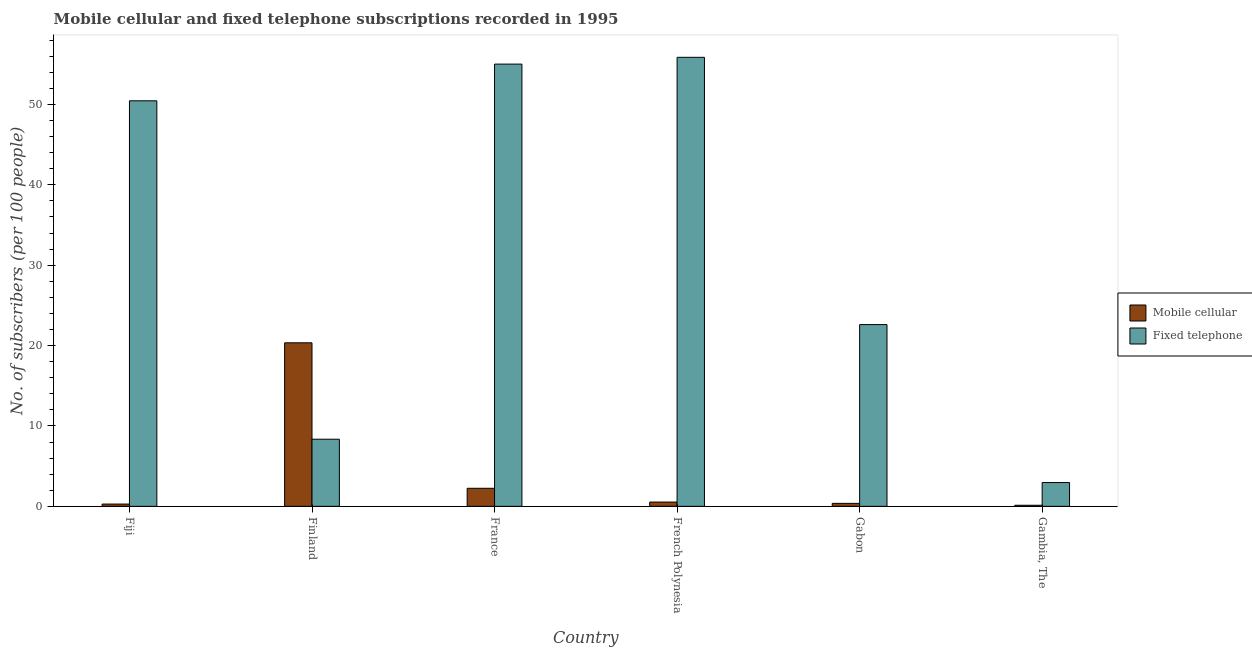How many different coloured bars are there?
Your answer should be very brief. 2. Are the number of bars on each tick of the X-axis equal?
Keep it short and to the point. Yes. How many bars are there on the 1st tick from the left?
Your answer should be very brief. 2. How many bars are there on the 6th tick from the right?
Make the answer very short. 2. What is the label of the 4th group of bars from the left?
Ensure brevity in your answer.  French Polynesia. What is the number of mobile cellular subscribers in France?
Offer a terse response. 2.25. Across all countries, what is the maximum number of mobile cellular subscribers?
Offer a terse response. 20.34. Across all countries, what is the minimum number of fixed telephone subscribers?
Your answer should be compact. 2.96. In which country was the number of fixed telephone subscribers maximum?
Give a very brief answer. French Polynesia. In which country was the number of mobile cellular subscribers minimum?
Ensure brevity in your answer.  Gambia, The. What is the total number of mobile cellular subscribers in the graph?
Ensure brevity in your answer.  23.91. What is the difference between the number of fixed telephone subscribers in Finland and that in Gambia, The?
Your answer should be very brief. 5.39. What is the difference between the number of fixed telephone subscribers in Finland and the number of mobile cellular subscribers in France?
Keep it short and to the point. 6.11. What is the average number of fixed telephone subscribers per country?
Offer a terse response. 32.54. What is the difference between the number of fixed telephone subscribers and number of mobile cellular subscribers in France?
Make the answer very short. 52.76. In how many countries, is the number of mobile cellular subscribers greater than 14 ?
Offer a terse response. 1. What is the ratio of the number of mobile cellular subscribers in France to that in Gambia, The?
Offer a terse response. 16.59. Is the number of mobile cellular subscribers in France less than that in Gambia, The?
Your answer should be compact. No. What is the difference between the highest and the second highest number of mobile cellular subscribers?
Make the answer very short. 18.1. What is the difference between the highest and the lowest number of fixed telephone subscribers?
Keep it short and to the point. 52.89. In how many countries, is the number of mobile cellular subscribers greater than the average number of mobile cellular subscribers taken over all countries?
Offer a terse response. 1. Is the sum of the number of fixed telephone subscribers in France and French Polynesia greater than the maximum number of mobile cellular subscribers across all countries?
Your answer should be compact. Yes. What does the 1st bar from the left in Finland represents?
Your answer should be compact. Mobile cellular. What does the 2nd bar from the right in Finland represents?
Provide a short and direct response. Mobile cellular. Are all the bars in the graph horizontal?
Your answer should be very brief. No. How many countries are there in the graph?
Provide a succinct answer. 6. Does the graph contain any zero values?
Your response must be concise. No. Where does the legend appear in the graph?
Provide a short and direct response. Center right. How are the legend labels stacked?
Ensure brevity in your answer.  Vertical. What is the title of the graph?
Offer a terse response. Mobile cellular and fixed telephone subscriptions recorded in 1995. Does "Investment" appear as one of the legend labels in the graph?
Provide a short and direct response. No. What is the label or title of the X-axis?
Ensure brevity in your answer.  Country. What is the label or title of the Y-axis?
Give a very brief answer. No. of subscribers (per 100 people). What is the No. of subscribers (per 100 people) in Mobile cellular in Fiji?
Keep it short and to the point. 0.28. What is the No. of subscribers (per 100 people) in Fixed telephone in Fiji?
Provide a short and direct response. 50.45. What is the No. of subscribers (per 100 people) of Mobile cellular in Finland?
Make the answer very short. 20.34. What is the No. of subscribers (per 100 people) of Fixed telephone in Finland?
Provide a succinct answer. 8.35. What is the No. of subscribers (per 100 people) of Mobile cellular in France?
Provide a short and direct response. 2.25. What is the No. of subscribers (per 100 people) in Fixed telephone in France?
Provide a short and direct response. 55.01. What is the No. of subscribers (per 100 people) in Mobile cellular in French Polynesia?
Your answer should be compact. 0.53. What is the No. of subscribers (per 100 people) in Fixed telephone in French Polynesia?
Ensure brevity in your answer.  55.85. What is the No. of subscribers (per 100 people) of Mobile cellular in Gabon?
Your answer should be very brief. 0.37. What is the No. of subscribers (per 100 people) of Fixed telephone in Gabon?
Provide a short and direct response. 22.61. What is the No. of subscribers (per 100 people) in Mobile cellular in Gambia, The?
Provide a short and direct response. 0.14. What is the No. of subscribers (per 100 people) of Fixed telephone in Gambia, The?
Your response must be concise. 2.96. Across all countries, what is the maximum No. of subscribers (per 100 people) of Mobile cellular?
Offer a terse response. 20.34. Across all countries, what is the maximum No. of subscribers (per 100 people) in Fixed telephone?
Your answer should be compact. 55.85. Across all countries, what is the minimum No. of subscribers (per 100 people) in Mobile cellular?
Make the answer very short. 0.14. Across all countries, what is the minimum No. of subscribers (per 100 people) of Fixed telephone?
Keep it short and to the point. 2.96. What is the total No. of subscribers (per 100 people) in Mobile cellular in the graph?
Make the answer very short. 23.91. What is the total No. of subscribers (per 100 people) of Fixed telephone in the graph?
Provide a succinct answer. 195.23. What is the difference between the No. of subscribers (per 100 people) in Mobile cellular in Fiji and that in Finland?
Your answer should be very brief. -20.06. What is the difference between the No. of subscribers (per 100 people) in Fixed telephone in Fiji and that in Finland?
Offer a terse response. 42.09. What is the difference between the No. of subscribers (per 100 people) in Mobile cellular in Fiji and that in France?
Your answer should be very brief. -1.96. What is the difference between the No. of subscribers (per 100 people) in Fixed telephone in Fiji and that in France?
Your answer should be very brief. -4.56. What is the difference between the No. of subscribers (per 100 people) in Mobile cellular in Fiji and that in French Polynesia?
Your answer should be very brief. -0.25. What is the difference between the No. of subscribers (per 100 people) of Fixed telephone in Fiji and that in French Polynesia?
Your answer should be compact. -5.41. What is the difference between the No. of subscribers (per 100 people) of Mobile cellular in Fiji and that in Gabon?
Make the answer very short. -0.09. What is the difference between the No. of subscribers (per 100 people) of Fixed telephone in Fiji and that in Gabon?
Your answer should be very brief. 27.84. What is the difference between the No. of subscribers (per 100 people) of Mobile cellular in Fiji and that in Gambia, The?
Make the answer very short. 0.15. What is the difference between the No. of subscribers (per 100 people) in Fixed telephone in Fiji and that in Gambia, The?
Offer a terse response. 47.48. What is the difference between the No. of subscribers (per 100 people) of Mobile cellular in Finland and that in France?
Offer a very short reply. 18.1. What is the difference between the No. of subscribers (per 100 people) in Fixed telephone in Finland and that in France?
Make the answer very short. -46.66. What is the difference between the No. of subscribers (per 100 people) in Mobile cellular in Finland and that in French Polynesia?
Make the answer very short. 19.81. What is the difference between the No. of subscribers (per 100 people) of Fixed telephone in Finland and that in French Polynesia?
Offer a terse response. -47.5. What is the difference between the No. of subscribers (per 100 people) in Mobile cellular in Finland and that in Gabon?
Make the answer very short. 19.97. What is the difference between the No. of subscribers (per 100 people) in Fixed telephone in Finland and that in Gabon?
Make the answer very short. -14.26. What is the difference between the No. of subscribers (per 100 people) in Mobile cellular in Finland and that in Gambia, The?
Your answer should be very brief. 20.21. What is the difference between the No. of subscribers (per 100 people) in Fixed telephone in Finland and that in Gambia, The?
Make the answer very short. 5.39. What is the difference between the No. of subscribers (per 100 people) in Mobile cellular in France and that in French Polynesia?
Provide a short and direct response. 1.71. What is the difference between the No. of subscribers (per 100 people) in Fixed telephone in France and that in French Polynesia?
Keep it short and to the point. -0.84. What is the difference between the No. of subscribers (per 100 people) of Mobile cellular in France and that in Gabon?
Provide a short and direct response. 1.88. What is the difference between the No. of subscribers (per 100 people) in Fixed telephone in France and that in Gabon?
Give a very brief answer. 32.4. What is the difference between the No. of subscribers (per 100 people) of Mobile cellular in France and that in Gambia, The?
Make the answer very short. 2.11. What is the difference between the No. of subscribers (per 100 people) in Fixed telephone in France and that in Gambia, The?
Ensure brevity in your answer.  52.05. What is the difference between the No. of subscribers (per 100 people) in Mobile cellular in French Polynesia and that in Gabon?
Provide a short and direct response. 0.16. What is the difference between the No. of subscribers (per 100 people) of Fixed telephone in French Polynesia and that in Gabon?
Provide a succinct answer. 33.24. What is the difference between the No. of subscribers (per 100 people) of Mobile cellular in French Polynesia and that in Gambia, The?
Offer a very short reply. 0.4. What is the difference between the No. of subscribers (per 100 people) in Fixed telephone in French Polynesia and that in Gambia, The?
Keep it short and to the point. 52.89. What is the difference between the No. of subscribers (per 100 people) in Mobile cellular in Gabon and that in Gambia, The?
Your answer should be very brief. 0.23. What is the difference between the No. of subscribers (per 100 people) in Fixed telephone in Gabon and that in Gambia, The?
Offer a terse response. 19.65. What is the difference between the No. of subscribers (per 100 people) of Mobile cellular in Fiji and the No. of subscribers (per 100 people) of Fixed telephone in Finland?
Your answer should be very brief. -8.07. What is the difference between the No. of subscribers (per 100 people) of Mobile cellular in Fiji and the No. of subscribers (per 100 people) of Fixed telephone in France?
Offer a terse response. -54.73. What is the difference between the No. of subscribers (per 100 people) of Mobile cellular in Fiji and the No. of subscribers (per 100 people) of Fixed telephone in French Polynesia?
Your answer should be compact. -55.57. What is the difference between the No. of subscribers (per 100 people) in Mobile cellular in Fiji and the No. of subscribers (per 100 people) in Fixed telephone in Gabon?
Provide a short and direct response. -22.33. What is the difference between the No. of subscribers (per 100 people) of Mobile cellular in Fiji and the No. of subscribers (per 100 people) of Fixed telephone in Gambia, The?
Provide a succinct answer. -2.68. What is the difference between the No. of subscribers (per 100 people) of Mobile cellular in Finland and the No. of subscribers (per 100 people) of Fixed telephone in France?
Make the answer very short. -34.67. What is the difference between the No. of subscribers (per 100 people) in Mobile cellular in Finland and the No. of subscribers (per 100 people) in Fixed telephone in French Polynesia?
Give a very brief answer. -35.51. What is the difference between the No. of subscribers (per 100 people) of Mobile cellular in Finland and the No. of subscribers (per 100 people) of Fixed telephone in Gabon?
Your answer should be compact. -2.27. What is the difference between the No. of subscribers (per 100 people) in Mobile cellular in Finland and the No. of subscribers (per 100 people) in Fixed telephone in Gambia, The?
Give a very brief answer. 17.38. What is the difference between the No. of subscribers (per 100 people) in Mobile cellular in France and the No. of subscribers (per 100 people) in Fixed telephone in French Polynesia?
Give a very brief answer. -53.61. What is the difference between the No. of subscribers (per 100 people) of Mobile cellular in France and the No. of subscribers (per 100 people) of Fixed telephone in Gabon?
Your answer should be very brief. -20.36. What is the difference between the No. of subscribers (per 100 people) in Mobile cellular in France and the No. of subscribers (per 100 people) in Fixed telephone in Gambia, The?
Offer a very short reply. -0.72. What is the difference between the No. of subscribers (per 100 people) in Mobile cellular in French Polynesia and the No. of subscribers (per 100 people) in Fixed telephone in Gabon?
Provide a succinct answer. -22.07. What is the difference between the No. of subscribers (per 100 people) in Mobile cellular in French Polynesia and the No. of subscribers (per 100 people) in Fixed telephone in Gambia, The?
Ensure brevity in your answer.  -2.43. What is the difference between the No. of subscribers (per 100 people) of Mobile cellular in Gabon and the No. of subscribers (per 100 people) of Fixed telephone in Gambia, The?
Offer a terse response. -2.59. What is the average No. of subscribers (per 100 people) of Mobile cellular per country?
Your response must be concise. 3.99. What is the average No. of subscribers (per 100 people) of Fixed telephone per country?
Offer a very short reply. 32.54. What is the difference between the No. of subscribers (per 100 people) of Mobile cellular and No. of subscribers (per 100 people) of Fixed telephone in Fiji?
Make the answer very short. -50.16. What is the difference between the No. of subscribers (per 100 people) in Mobile cellular and No. of subscribers (per 100 people) in Fixed telephone in Finland?
Ensure brevity in your answer.  11.99. What is the difference between the No. of subscribers (per 100 people) of Mobile cellular and No. of subscribers (per 100 people) of Fixed telephone in France?
Your response must be concise. -52.76. What is the difference between the No. of subscribers (per 100 people) of Mobile cellular and No. of subscribers (per 100 people) of Fixed telephone in French Polynesia?
Your answer should be compact. -55.32. What is the difference between the No. of subscribers (per 100 people) in Mobile cellular and No. of subscribers (per 100 people) in Fixed telephone in Gabon?
Give a very brief answer. -22.24. What is the difference between the No. of subscribers (per 100 people) of Mobile cellular and No. of subscribers (per 100 people) of Fixed telephone in Gambia, The?
Offer a terse response. -2.83. What is the ratio of the No. of subscribers (per 100 people) of Mobile cellular in Fiji to that in Finland?
Your response must be concise. 0.01. What is the ratio of the No. of subscribers (per 100 people) in Fixed telephone in Fiji to that in Finland?
Your response must be concise. 6.04. What is the ratio of the No. of subscribers (per 100 people) in Mobile cellular in Fiji to that in France?
Your response must be concise. 0.13. What is the ratio of the No. of subscribers (per 100 people) in Fixed telephone in Fiji to that in France?
Ensure brevity in your answer.  0.92. What is the ratio of the No. of subscribers (per 100 people) in Mobile cellular in Fiji to that in French Polynesia?
Make the answer very short. 0.53. What is the ratio of the No. of subscribers (per 100 people) in Fixed telephone in Fiji to that in French Polynesia?
Your answer should be very brief. 0.9. What is the ratio of the No. of subscribers (per 100 people) in Mobile cellular in Fiji to that in Gabon?
Ensure brevity in your answer.  0.77. What is the ratio of the No. of subscribers (per 100 people) in Fixed telephone in Fiji to that in Gabon?
Your answer should be compact. 2.23. What is the ratio of the No. of subscribers (per 100 people) of Mobile cellular in Fiji to that in Gambia, The?
Give a very brief answer. 2.1. What is the ratio of the No. of subscribers (per 100 people) in Fixed telephone in Fiji to that in Gambia, The?
Keep it short and to the point. 17.03. What is the ratio of the No. of subscribers (per 100 people) in Mobile cellular in Finland to that in France?
Offer a very short reply. 9.06. What is the ratio of the No. of subscribers (per 100 people) of Fixed telephone in Finland to that in France?
Offer a terse response. 0.15. What is the ratio of the No. of subscribers (per 100 people) in Mobile cellular in Finland to that in French Polynesia?
Offer a terse response. 38.07. What is the ratio of the No. of subscribers (per 100 people) in Fixed telephone in Finland to that in French Polynesia?
Offer a terse response. 0.15. What is the ratio of the No. of subscribers (per 100 people) in Mobile cellular in Finland to that in Gabon?
Keep it short and to the point. 54.95. What is the ratio of the No. of subscribers (per 100 people) of Fixed telephone in Finland to that in Gabon?
Ensure brevity in your answer.  0.37. What is the ratio of the No. of subscribers (per 100 people) in Mobile cellular in Finland to that in Gambia, The?
Give a very brief answer. 150.35. What is the ratio of the No. of subscribers (per 100 people) in Fixed telephone in Finland to that in Gambia, The?
Ensure brevity in your answer.  2.82. What is the ratio of the No. of subscribers (per 100 people) of Mobile cellular in France to that in French Polynesia?
Your answer should be compact. 4.2. What is the ratio of the No. of subscribers (per 100 people) of Fixed telephone in France to that in French Polynesia?
Provide a short and direct response. 0.98. What is the ratio of the No. of subscribers (per 100 people) of Mobile cellular in France to that in Gabon?
Provide a short and direct response. 6.07. What is the ratio of the No. of subscribers (per 100 people) of Fixed telephone in France to that in Gabon?
Give a very brief answer. 2.43. What is the ratio of the No. of subscribers (per 100 people) in Mobile cellular in France to that in Gambia, The?
Offer a very short reply. 16.59. What is the ratio of the No. of subscribers (per 100 people) in Fixed telephone in France to that in Gambia, The?
Keep it short and to the point. 18.57. What is the ratio of the No. of subscribers (per 100 people) in Mobile cellular in French Polynesia to that in Gabon?
Make the answer very short. 1.44. What is the ratio of the No. of subscribers (per 100 people) of Fixed telephone in French Polynesia to that in Gabon?
Keep it short and to the point. 2.47. What is the ratio of the No. of subscribers (per 100 people) of Mobile cellular in French Polynesia to that in Gambia, The?
Give a very brief answer. 3.95. What is the ratio of the No. of subscribers (per 100 people) of Fixed telephone in French Polynesia to that in Gambia, The?
Provide a succinct answer. 18.86. What is the ratio of the No. of subscribers (per 100 people) of Mobile cellular in Gabon to that in Gambia, The?
Ensure brevity in your answer.  2.74. What is the ratio of the No. of subscribers (per 100 people) of Fixed telephone in Gabon to that in Gambia, The?
Provide a short and direct response. 7.63. What is the difference between the highest and the second highest No. of subscribers (per 100 people) of Mobile cellular?
Provide a short and direct response. 18.1. What is the difference between the highest and the second highest No. of subscribers (per 100 people) in Fixed telephone?
Ensure brevity in your answer.  0.84. What is the difference between the highest and the lowest No. of subscribers (per 100 people) in Mobile cellular?
Offer a very short reply. 20.21. What is the difference between the highest and the lowest No. of subscribers (per 100 people) of Fixed telephone?
Ensure brevity in your answer.  52.89. 